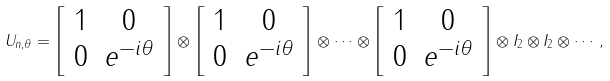<formula> <loc_0><loc_0><loc_500><loc_500>U _ { n , \theta } = \left [ \begin{array} { c c } 1 & 0 \\ 0 & e ^ { - i \theta } \end{array} \right ] \otimes \left [ \begin{array} { c c } 1 & 0 \\ 0 & e ^ { - i \theta } \end{array} \right ] \otimes \cdots \otimes \left [ \begin{array} { c c } 1 & 0 \\ 0 & e ^ { - i \theta } \end{array} \right ] \otimes I _ { 2 } \otimes I _ { 2 } \otimes \cdots ,</formula> 